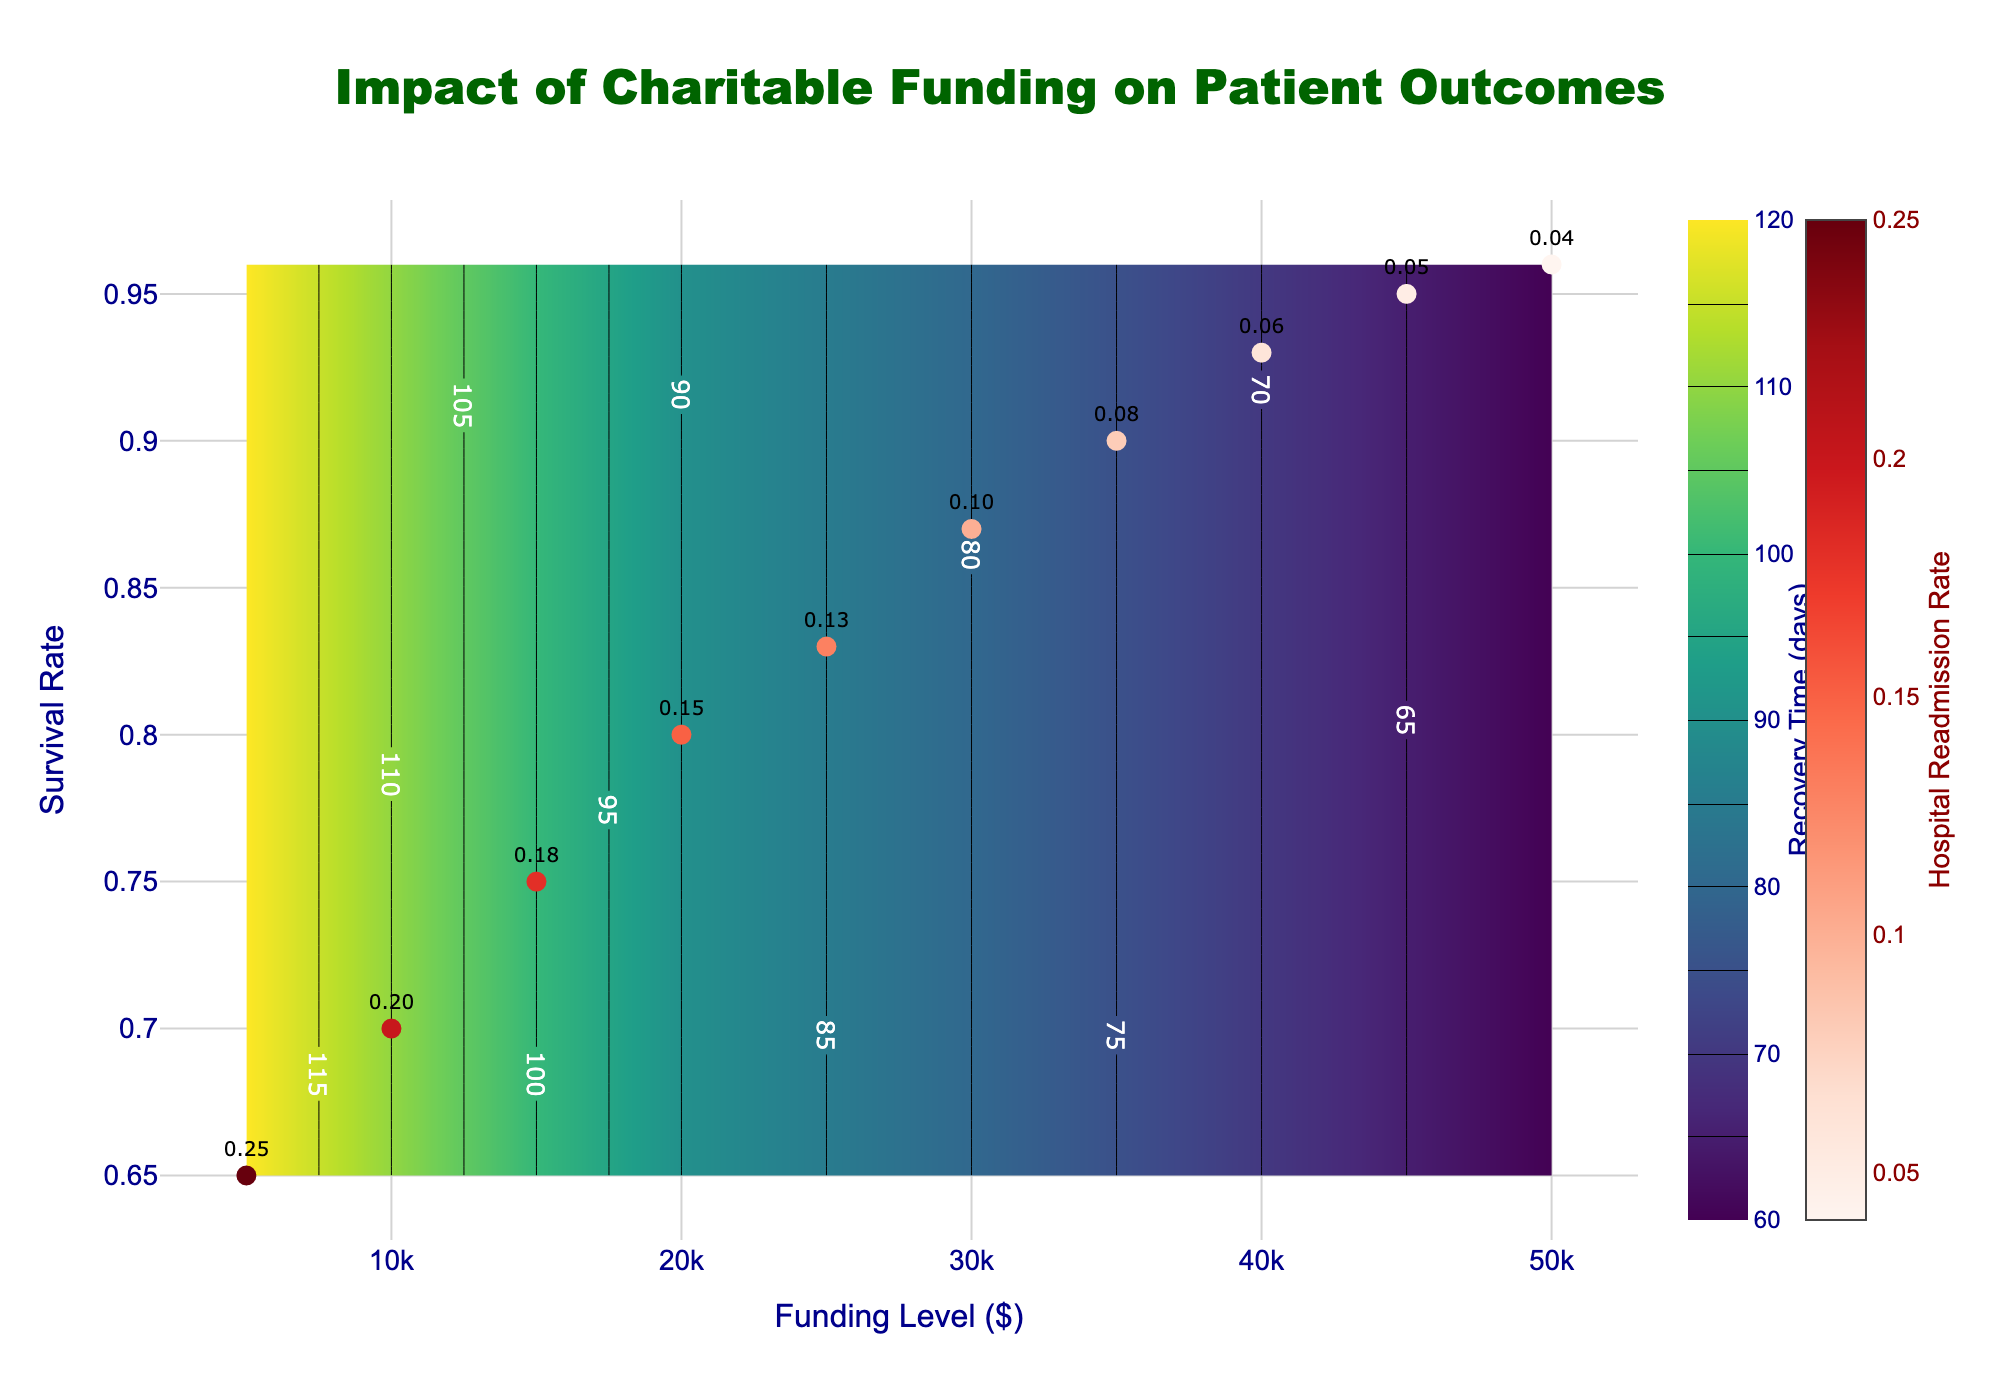What is the title of the figure? The title of the figure is generally placed at the top center of the plot area. In this case, the title can be easily read from its location.
Answer: Impact of Charitable Funding on Patient Outcomes How many funding levels are displayed in the scatter plot? By counting the number of distinct markers on the scatter plot, we can determine the number of distinct funding levels. Each marker represents one funding level from the dataset.
Answer: 10 What is the color of the contour plot's heatmap? The heatmap color can be identified based on the color scheme used in the contour plot. Here, we look for the name of the color scale that has been used.
Answer: Viridis What does the colorbar on the right of the scatter plot represent? The label and title of the colorbar indicate what it represents. In this case, read the title on the scatter plot's colorbar.
Answer: Hospital Readmission Rate What is the relationship between the 'Funding Level' and 'Survival Rate'? Observe how the 'Survival Rate' changes as the 'Funding Level' increases by tracking the data points on the scatter plot. Note the general trend between these two variables.
Answer: As the funding level increases, the survival rate generally increases Between funding levels $5000 and $25000, how does recovery time change? Locate the corresponding data points on the funding level axis and then read the recovery time from the heatmap color intensity. Compare their recovery times.
Answer: It decreases from 120 days to 85 days Which data point has the lowest hospital readmission rate, and what is the corresponding funding level? Identify the scatter plot marker with the lowest hospital readmission rate value (given as a text label) and then find its corresponding funding level value on the x-axis.
Answer: Funding Level 50000 What is the range of survival rates displayed in the plot? Find the minimum and maximum values along the survival rate axis to determine the range.
Answer: 0.65 to 0.96 At what funding level does the recovery time drop below 80 days? Locate recovery times on the heatmap and find the funding level at which the contour for 80 days recovery time appears.
Answer: Around $30000 How does the hospital readmission rate trend as the funding level increases from $5000 to $50000? Look at the text labels on the scatter plot markers that indicate the hospital readmission rate and observe the trend as the funding level increases.
Answer: It decreases from 0.25 to 0.04 